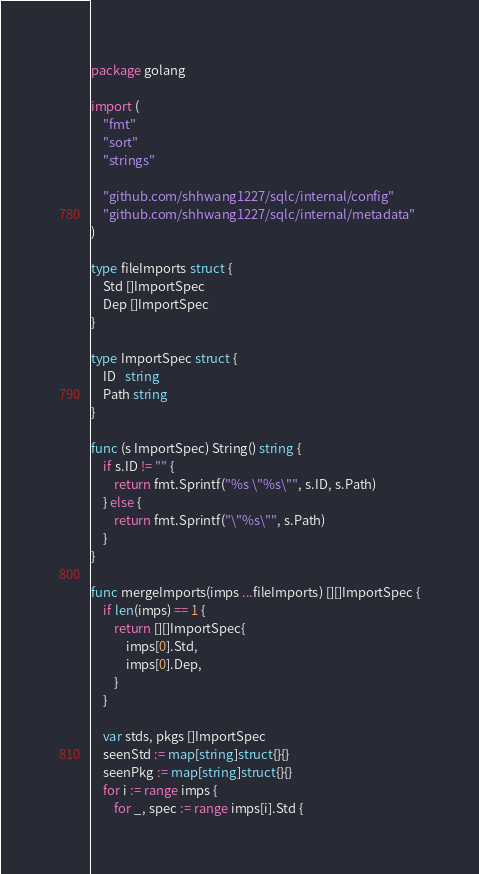Convert code to text. <code><loc_0><loc_0><loc_500><loc_500><_Go_>package golang

import (
	"fmt"
	"sort"
	"strings"

	"github.com/shhwang1227/sqlc/internal/config"
	"github.com/shhwang1227/sqlc/internal/metadata"
)

type fileImports struct {
	Std []ImportSpec
	Dep []ImportSpec
}

type ImportSpec struct {
	ID   string
	Path string
}

func (s ImportSpec) String() string {
	if s.ID != "" {
		return fmt.Sprintf("%s \"%s\"", s.ID, s.Path)
	} else {
		return fmt.Sprintf("\"%s\"", s.Path)
	}
}

func mergeImports(imps ...fileImports) [][]ImportSpec {
	if len(imps) == 1 {
		return [][]ImportSpec{
			imps[0].Std,
			imps[0].Dep,
		}
	}

	var stds, pkgs []ImportSpec
	seenStd := map[string]struct{}{}
	seenPkg := map[string]struct{}{}
	for i := range imps {
		for _, spec := range imps[i].Std {</code> 